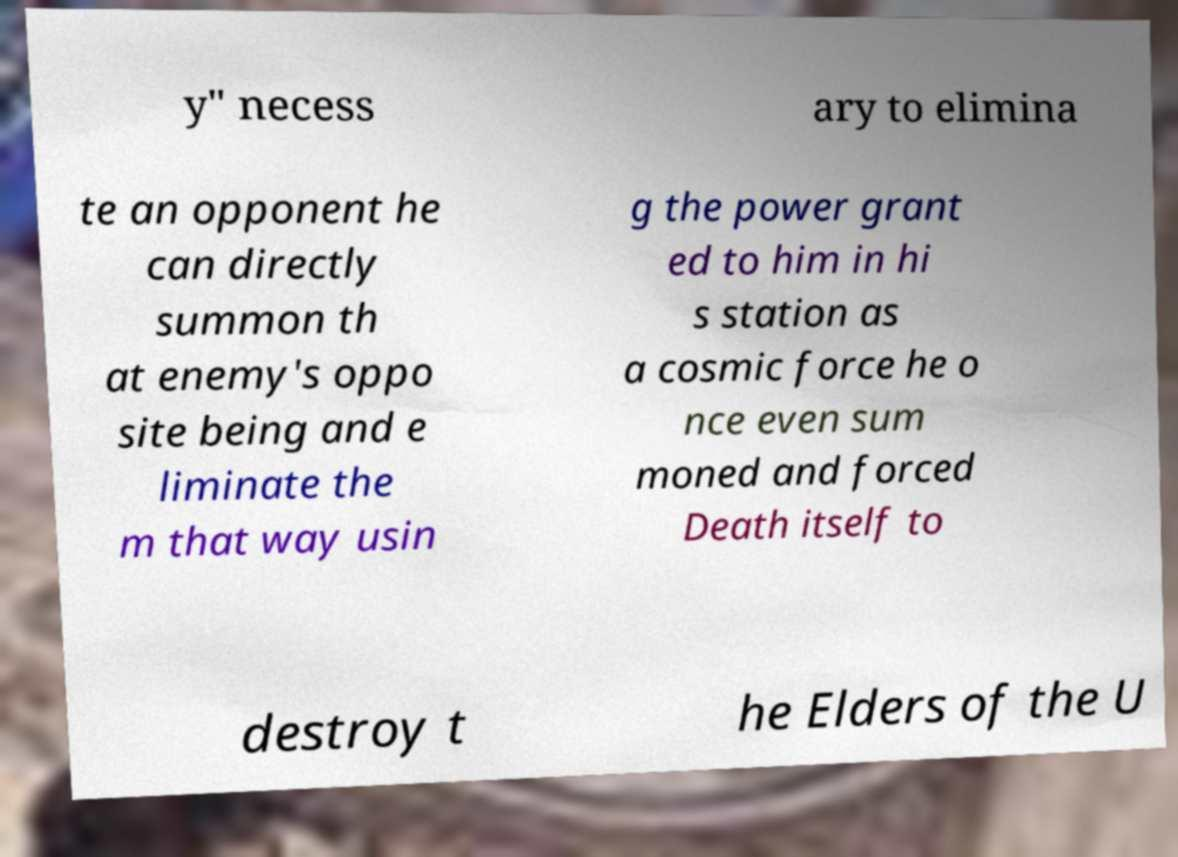What messages or text are displayed in this image? I need them in a readable, typed format. y" necess ary to elimina te an opponent he can directly summon th at enemy's oppo site being and e liminate the m that way usin g the power grant ed to him in hi s station as a cosmic force he o nce even sum moned and forced Death itself to destroy t he Elders of the U 